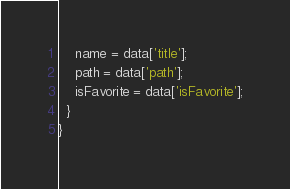<code> <loc_0><loc_0><loc_500><loc_500><_Dart_>    name = data['title'];
    path = data['path'];
    isFavorite = data['isFavorite'];
  }
}
</code> 